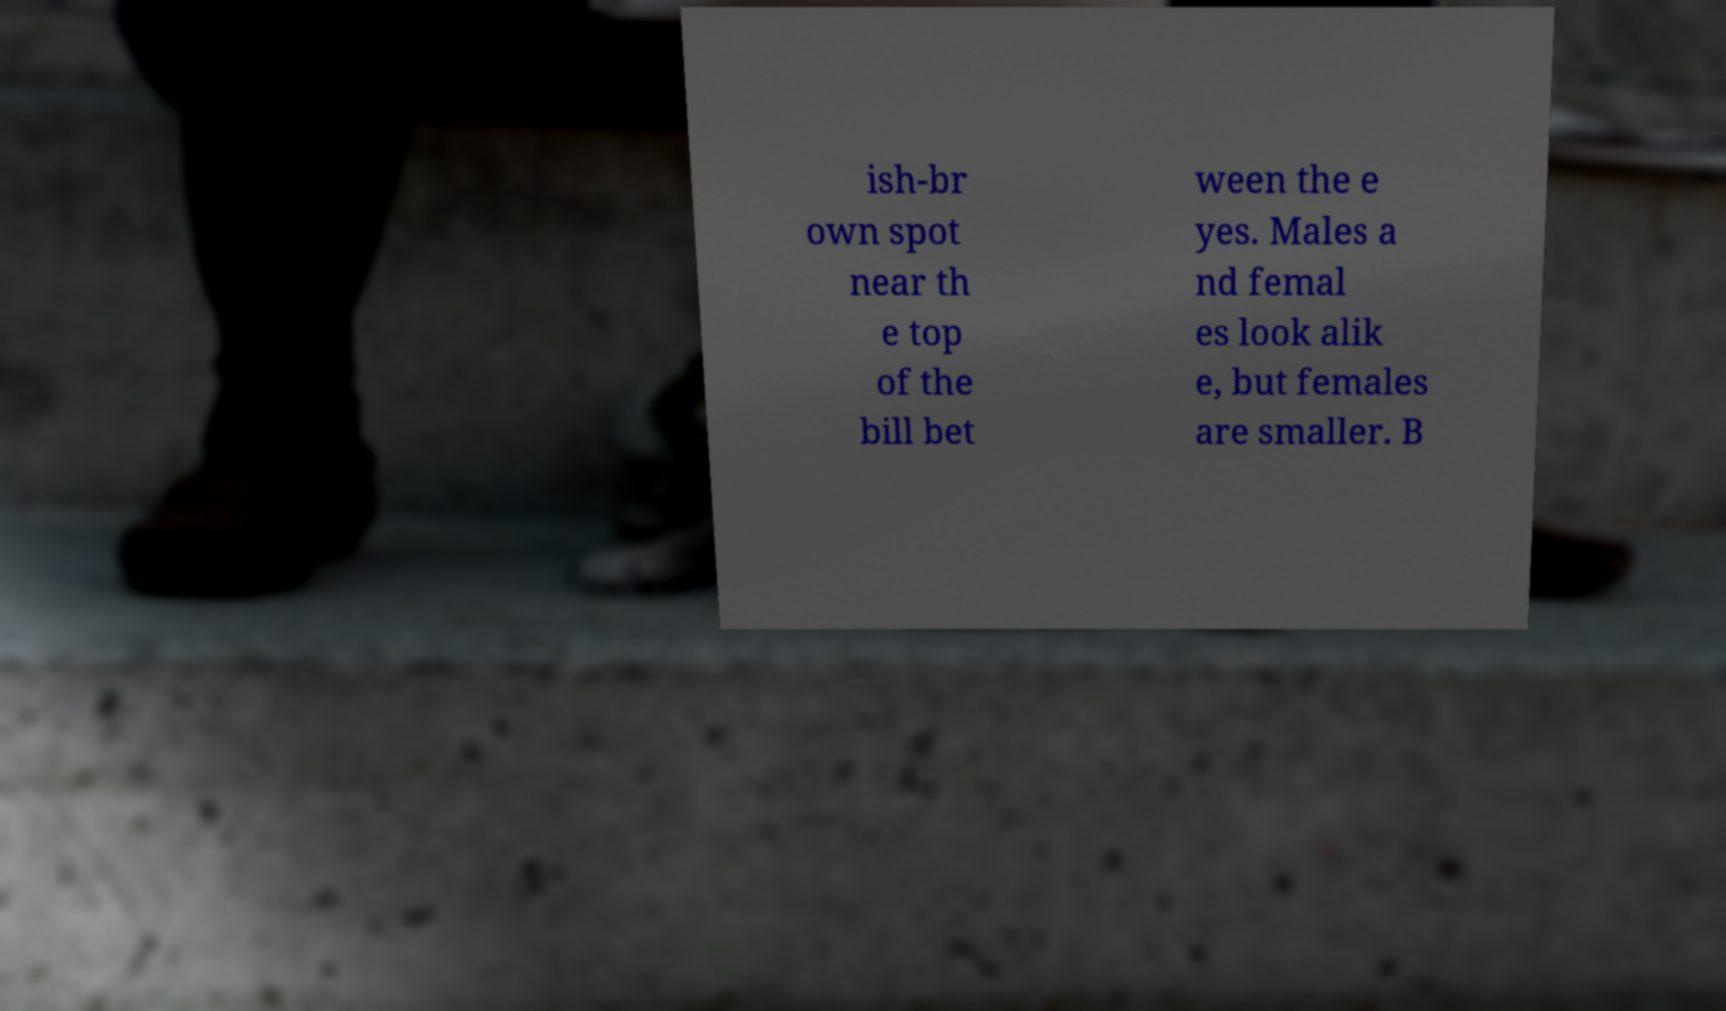Could you assist in decoding the text presented in this image and type it out clearly? ish-br own spot near th e top of the bill bet ween the e yes. Males a nd femal es look alik e, but females are smaller. B 